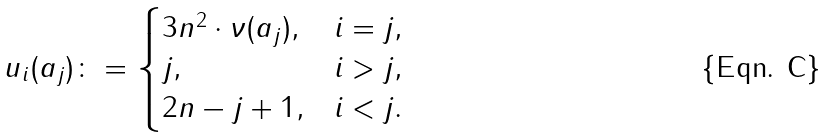<formula> <loc_0><loc_0><loc_500><loc_500>u _ { i } ( a _ { j } ) \colon = \begin{cases} 3 n ^ { 2 } \cdot \nu ( a _ { j } ) , & i = j , \\ j , & i > j , \\ 2 n - j + 1 , & i < j . \end{cases}</formula> 